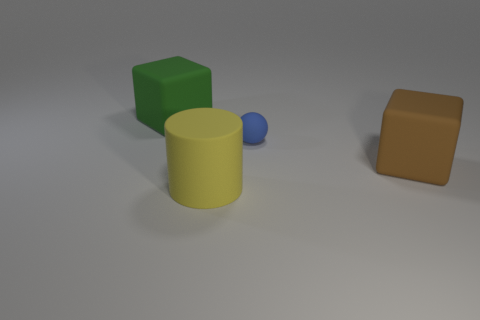Can you tell me the colors of all the large objects in the image? Certainly! There are two large objects in the image: one is yellow, and the other is blue. 